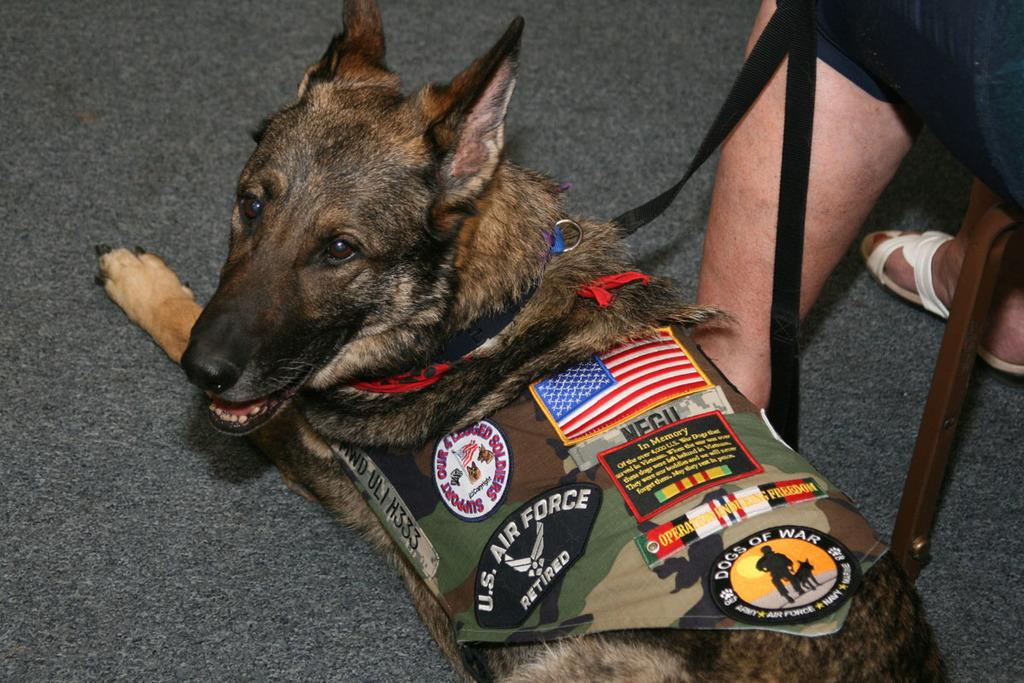What type of animal is in the image? There is a dog in the image. What is the dog wearing? The dog is wearing a belt. Whose legs are visible in the image? The legs of a person are visible in the image. What is the surface on which the dog and person are standing? The ground is visible in the image. What type of quill is the dog using to write in the image? There is no quill present in the image, and the dog is not writing. How much dirt can be seen on the dog's paws in the image? There is no dirt visible on the dog's paws in the image. 